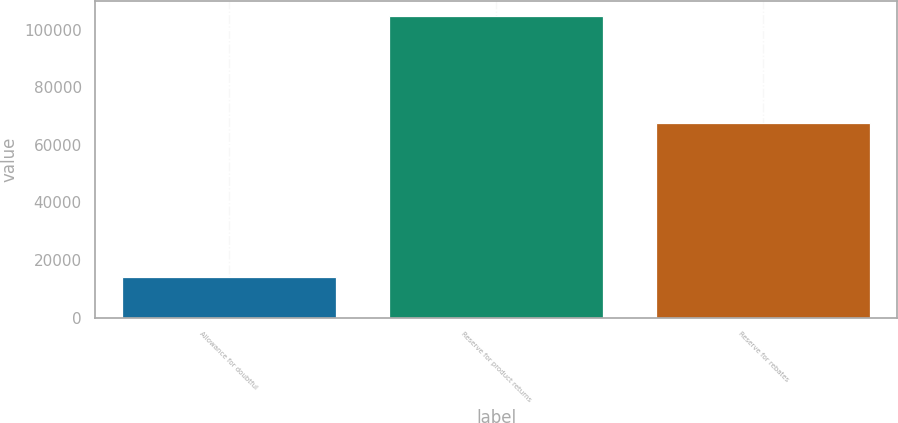Convert chart. <chart><loc_0><loc_0><loc_500><loc_500><bar_chart><fcel>Allowance for doubtful<fcel>Reserve for product returns<fcel>Reserve for rebates<nl><fcel>14269<fcel>104676<fcel>67399<nl></chart> 